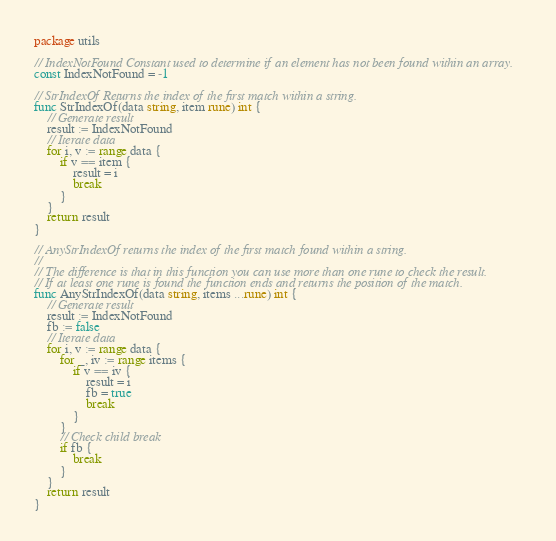<code> <loc_0><loc_0><loc_500><loc_500><_Go_>package utils

// IndexNotFound Constant used to determine if an element has not been found within an array.
const IndexNotFound = -1

// StrIndexOf Returns the index of the first match within a string.
func StrIndexOf(data string, item rune) int {
	// Generate result
	result := IndexNotFound
	// Iterate data
	for i, v := range data {
		if v == item {
			result = i
			break
		}
	}
	return result
}

// AnyStrIndexOf returns the index of the first match found within a string.
//
// The difference is that in this function you can use more than one rune to check the result.
// If at least one rune is found the function ends and returns the position of the match.
func AnyStrIndexOf(data string, items ...rune) int {
	// Generate result
	result := IndexNotFound
	fb := false
	// Iterate data
	for i, v := range data {
		for _, iv := range items {
			if v == iv {
				result = i
				fb = true
				break
			}
		}
		// Check child break
		if fb {
			break
		}
	}
	return result
}
</code> 